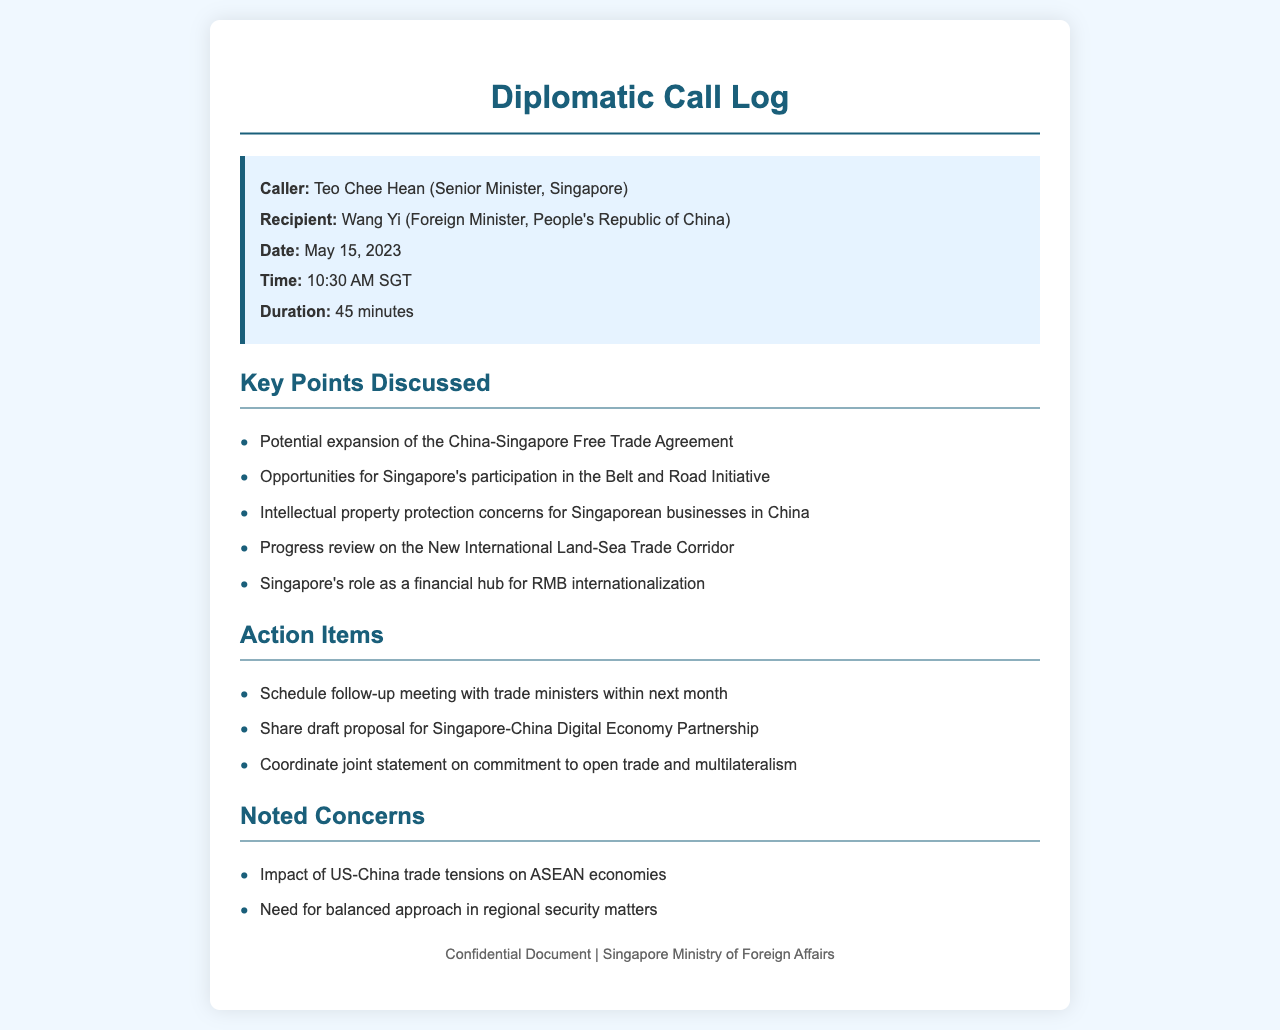What is the name of the caller? The caller is identified as Teo Chee Hean in the call log.
Answer: Teo Chee Hean Who was the recipient of the call? The recipient of the call is Wang Yi, as mentioned in the document.
Answer: Wang Yi What was the date of the call? The date of the call is explicitly stated in the document as May 15, 2023.
Answer: May 15, 2023 How long was the duration of the call? The duration of the call is noted as 45 minutes in the call log.
Answer: 45 minutes What key opportunity was discussed related to Singapore's involvement? The document mentions opportunities for Singapore's participation in the Belt and Road Initiative.
Answer: Belt and Road Initiative What was one of the noted concerns during the call? One of the concerns mentioned is the impact of US-China trade tensions on ASEAN economies.
Answer: US-China trade tensions What action item involves sharing a proposal? The document states to share a draft proposal for Singapore-China Digital Economy Partnership as an action item.
Answer: Share draft proposal What should be coordinated as an action item? The document mentions coordinating a joint statement on commitment to open trade and multilateralism.
Answer: Joint statement What type of document is this? The document is classified as a diplomatic call log, specifically detailing a conversation between political figures.
Answer: Diplomatic call log 